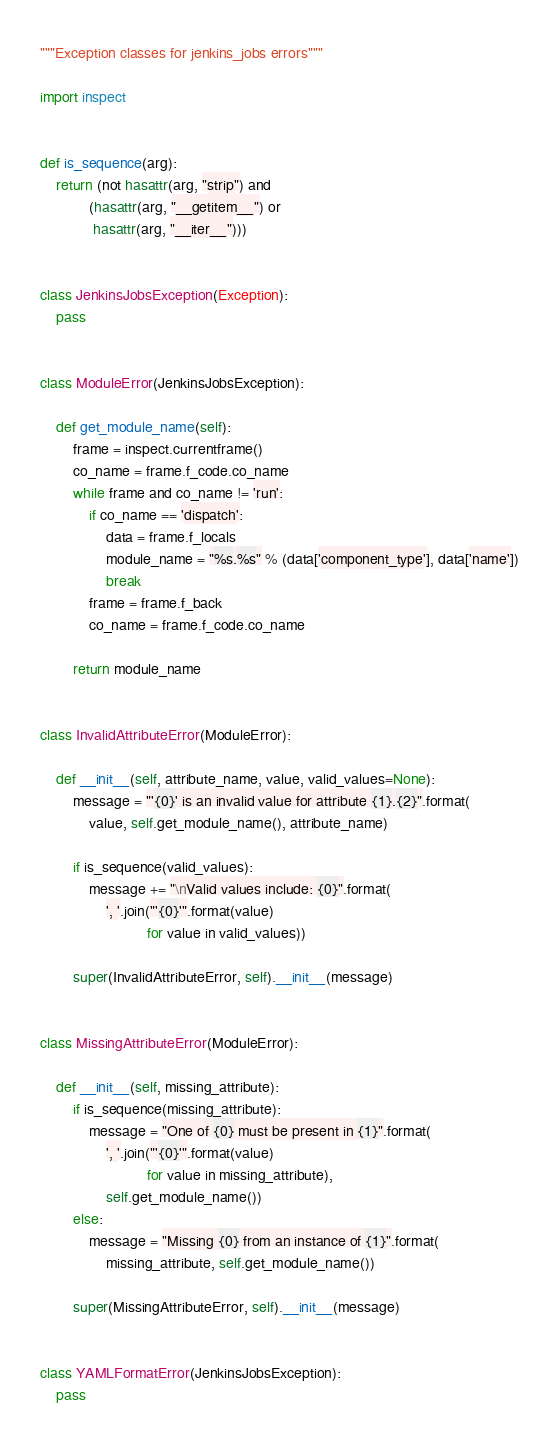<code> <loc_0><loc_0><loc_500><loc_500><_Python_>"""Exception classes for jenkins_jobs errors"""

import inspect


def is_sequence(arg):
    return (not hasattr(arg, "strip") and
            (hasattr(arg, "__getitem__") or
             hasattr(arg, "__iter__")))


class JenkinsJobsException(Exception):
    pass


class ModuleError(JenkinsJobsException):

    def get_module_name(self):
        frame = inspect.currentframe()
        co_name = frame.f_code.co_name
        while frame and co_name != 'run':
            if co_name == 'dispatch':
                data = frame.f_locals
                module_name = "%s.%s" % (data['component_type'], data['name'])
                break
            frame = frame.f_back
            co_name = frame.f_code.co_name

        return module_name


class InvalidAttributeError(ModuleError):

    def __init__(self, attribute_name, value, valid_values=None):
        message = "'{0}' is an invalid value for attribute {1}.{2}".format(
            value, self.get_module_name(), attribute_name)

        if is_sequence(valid_values):
            message += "\nValid values include: {0}".format(
                ', '.join("'{0}'".format(value)
                          for value in valid_values))

        super(InvalidAttributeError, self).__init__(message)


class MissingAttributeError(ModuleError):

    def __init__(self, missing_attribute):
        if is_sequence(missing_attribute):
            message = "One of {0} must be present in {1}".format(
                ', '.join("'{0}'".format(value)
                          for value in missing_attribute),
                self.get_module_name())
        else:
            message = "Missing {0} from an instance of {1}".format(
                missing_attribute, self.get_module_name())

        super(MissingAttributeError, self).__init__(message)


class YAMLFormatError(JenkinsJobsException):
    pass
</code> 